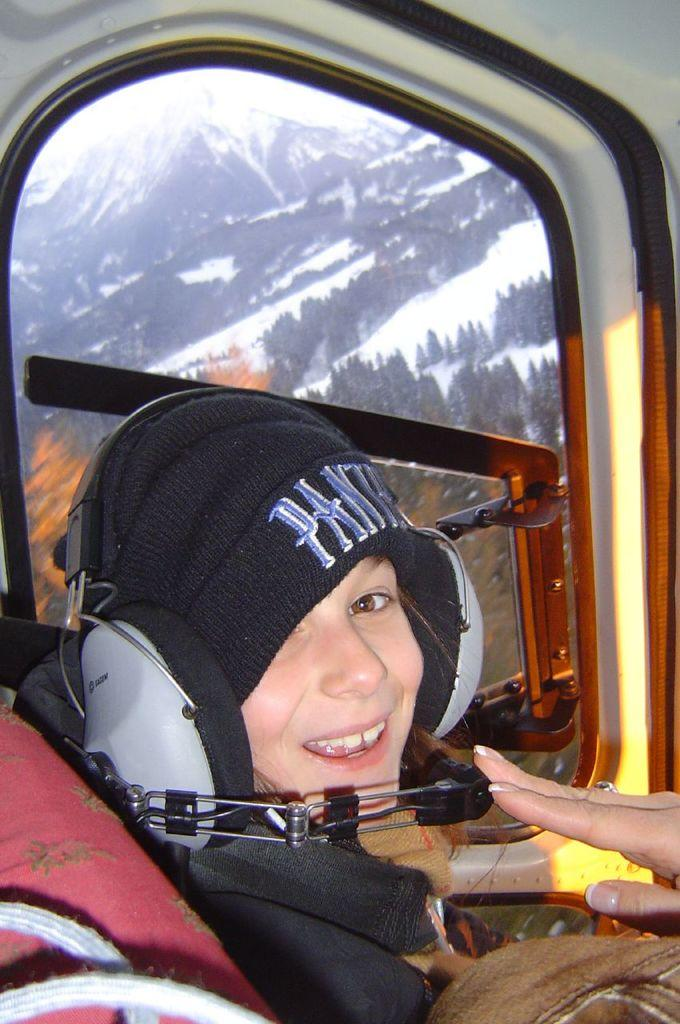What is present in the image? There is a person and a window in the image. What can be seen through the window? Mountains are visible in the image through the window. What type of yam is being used to protest in the image? There is no yam or protest present in the image; it features a person and a window with a view of mountains. 